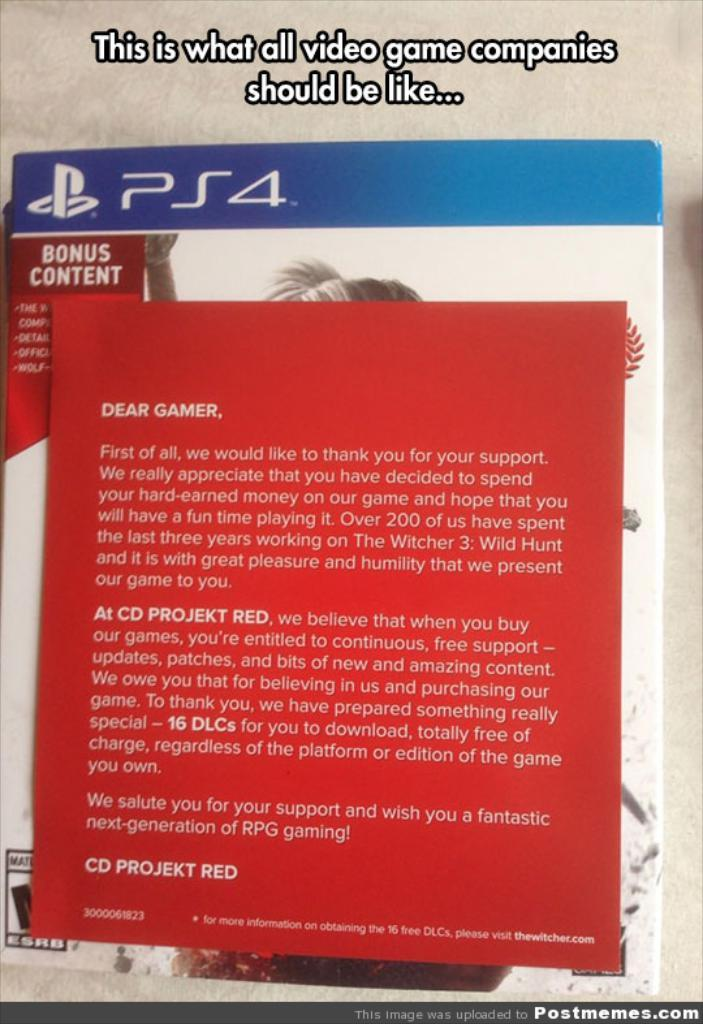<image>
Describe the image concisely. Red manual for a video game that was from "CD Projekt Red". 